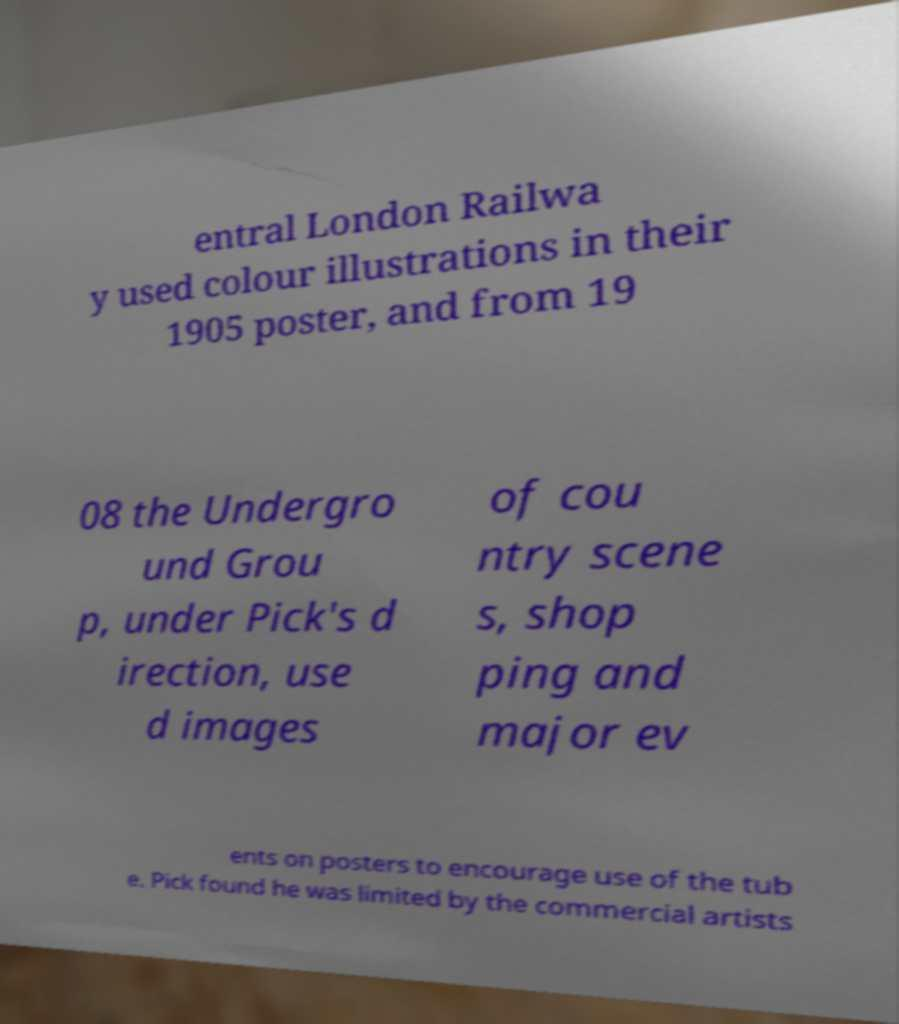Could you extract and type out the text from this image? entral London Railwa y used colour illustrations in their 1905 poster, and from 19 08 the Undergro und Grou p, under Pick's d irection, use d images of cou ntry scene s, shop ping and major ev ents on posters to encourage use of the tub e. Pick found he was limited by the commercial artists 